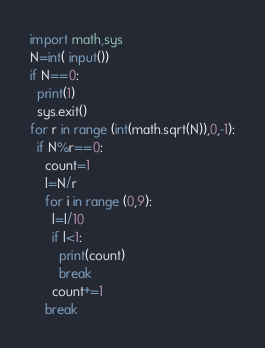<code> <loc_0><loc_0><loc_500><loc_500><_Python_>import math,sys
N=int( input())
if N==0:
  print(1)
  sys.exit()
for r in range (int(math.sqrt(N)),0,-1):
  if N%r==0:
    count=1
    l=N/r
    for i in range (0,9):
      l=l/10
      if l<1:
        print(count)
        break
      count+=1
    break</code> 